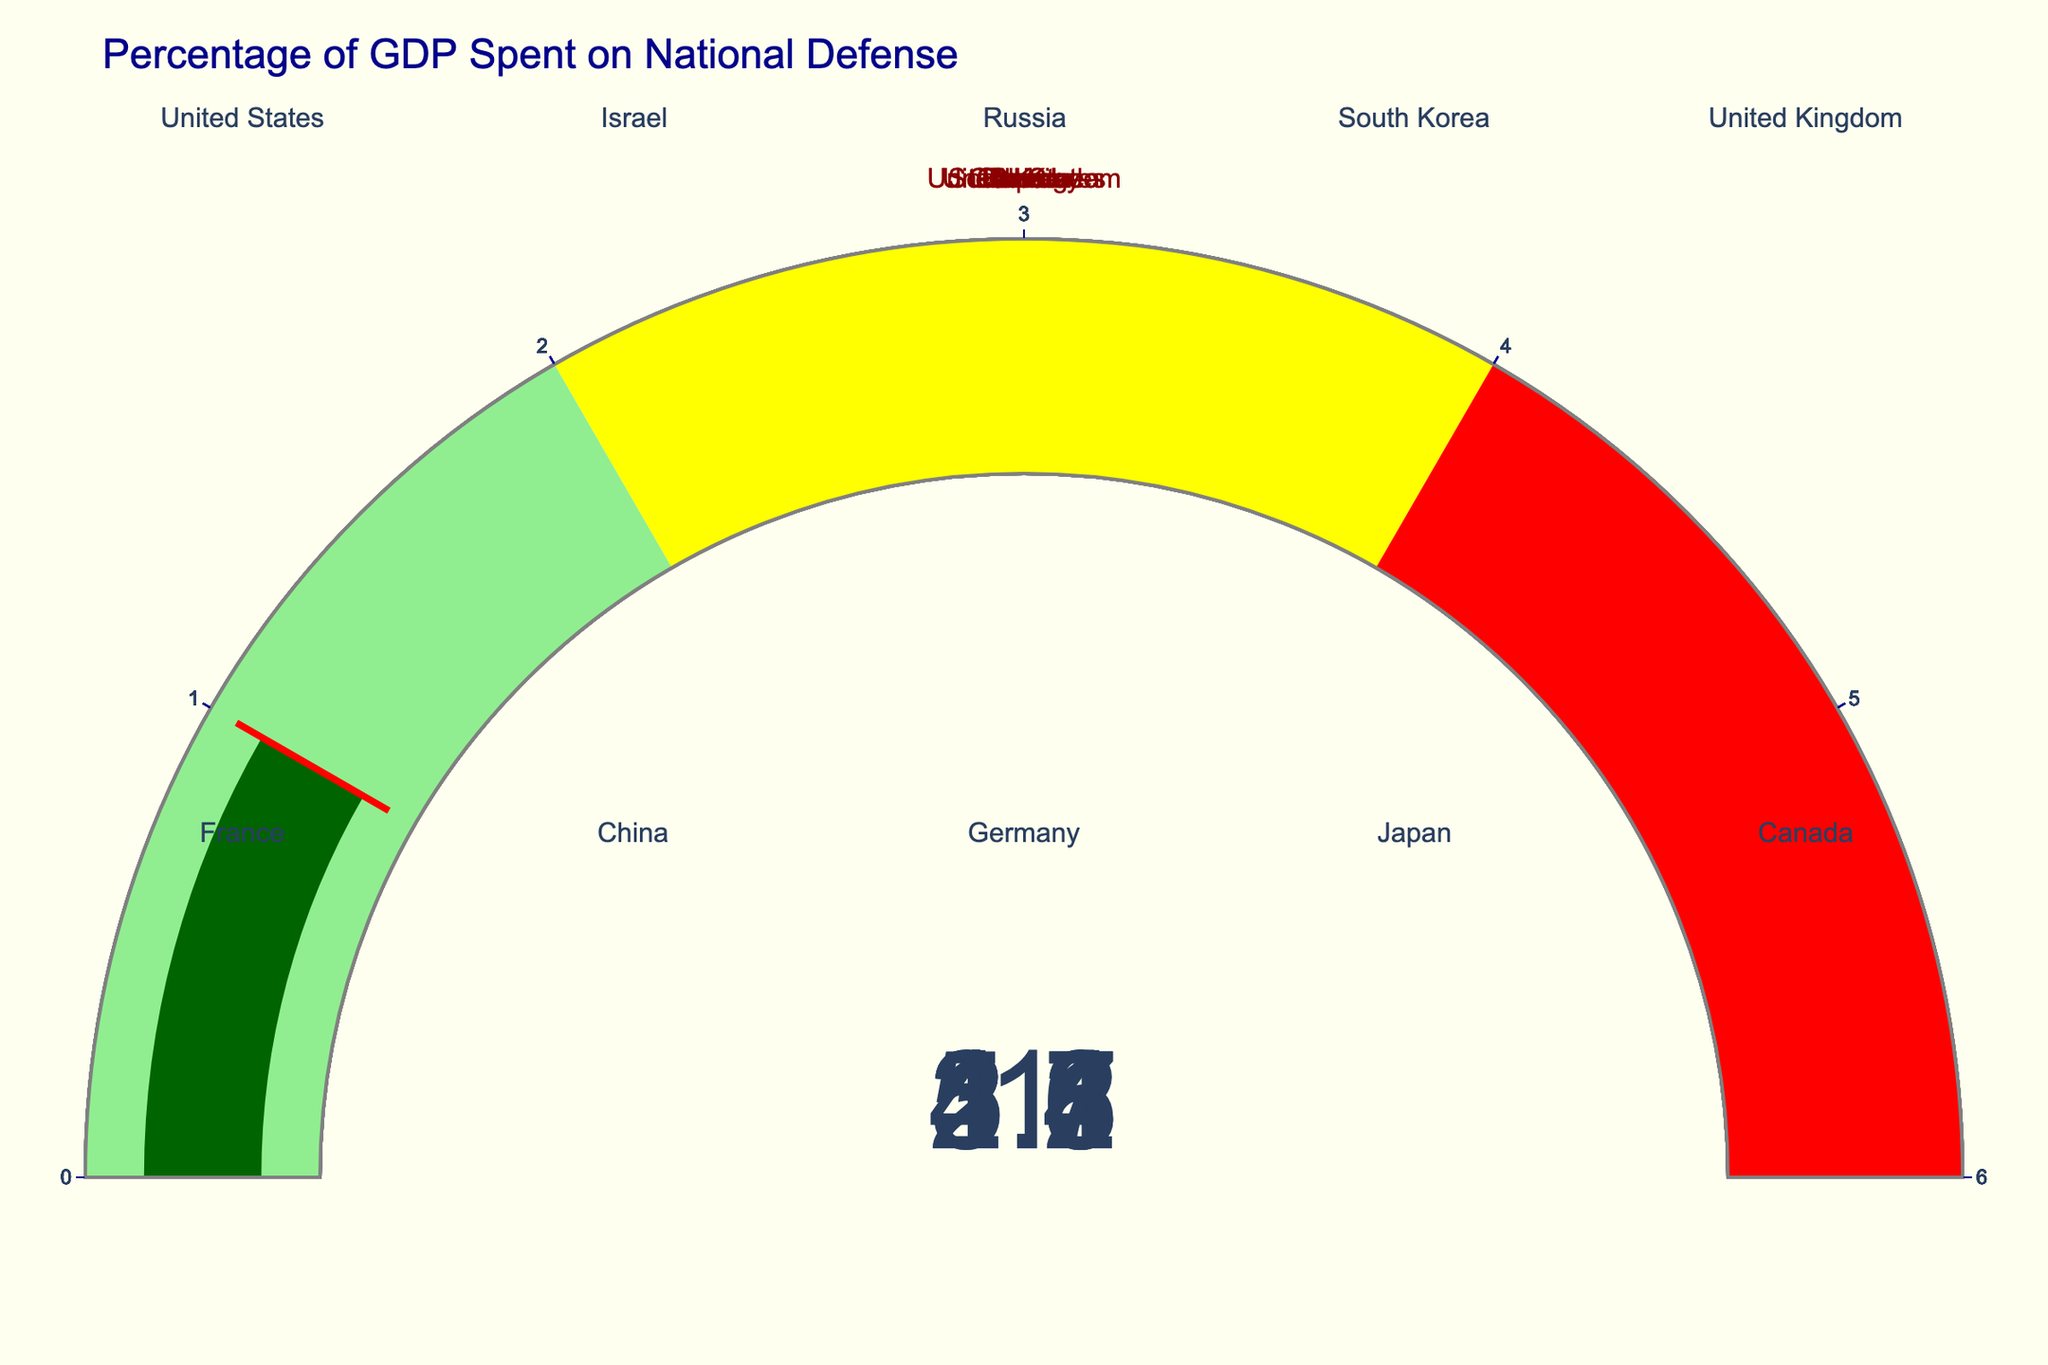Which country spends the highest percentage of GDP on national defense? The United States has the highest value on its gauge, indicating it spends the most.
Answer: Israel What is the average GDP percentage spent on defense by the five countries with the highest spending? Add the percentages of Israel (5.6), Russia (4.3), United States (3.7), South Korea (2.8), and United Kingdom (2.2) and divide by 5 to get the average.
Answer: 3.72 Which country spends the lowest percentage of its GDP on national defense? The lowest gauge value corresponds to Japan.
Answer: Japan How much higher is Israel's defense spending as a percentage of GDP compared to France's? Subtract France's percentage (2.1) from Israel's percentage (5.6).
Answer: 3.5 What is the combined GDP percentage spent on defense by China and Germany? Add the percentages of China (1.7) and Germany (1.4).
Answer: 3.1 Which country has a percentage of GDP spent on defense that falls within the yellow section of the gauge chart? South Korea (2.8) and United Kingdom (2.2) fall within the yellow section (2-4).
Answer: South Korea and United Kingdom Among the countries shown, how many spend less than 2% of their GDP on national defense? Count the countries with a gauge value less than 2%: China, Germany, Japan, and Canada.
Answer: 4 What is the difference in defense spending percentage between South Korea and Canada? Subtract Canada's percentage (1.3) from South Korea's percentage (2.8).
Answer: 1.5 Which two countries have gauge values closest to each other? Compare the gauge values and find the smallest difference, which is between Japan (1.0) and Canada (1.3).
Answer: Japan and Canada Considering the three countries with the lowest defense spending percentages, what is their average spending? Add the percentages of Japan (1.0), Germany (1.4), and Canada (1.3) and divide by 3.
Answer: 1.23 